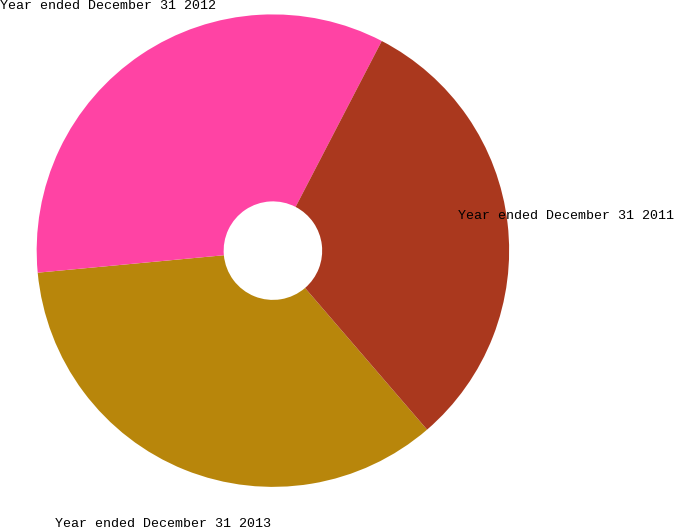Convert chart to OTSL. <chart><loc_0><loc_0><loc_500><loc_500><pie_chart><fcel>Year ended December 31 2013<fcel>Year ended December 31 2012<fcel>Year ended December 31 2011<nl><fcel>34.83%<fcel>34.11%<fcel>31.06%<nl></chart> 